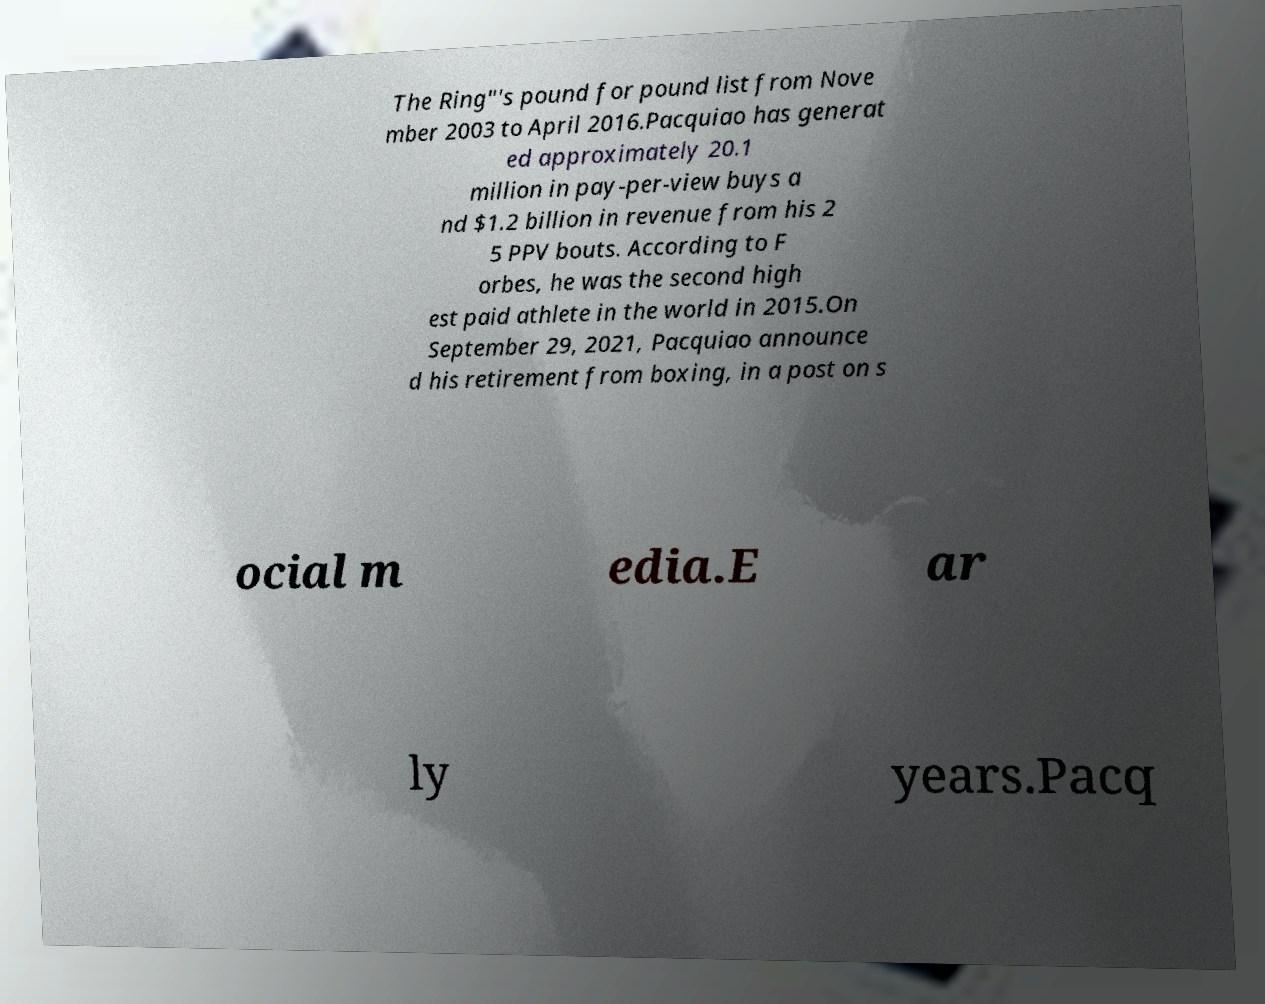Please read and relay the text visible in this image. What does it say? The Ring"'s pound for pound list from Nove mber 2003 to April 2016.Pacquiao has generat ed approximately 20.1 million in pay-per-view buys a nd $1.2 billion in revenue from his 2 5 PPV bouts. According to F orbes, he was the second high est paid athlete in the world in 2015.On September 29, 2021, Pacquiao announce d his retirement from boxing, in a post on s ocial m edia.E ar ly years.Pacq 